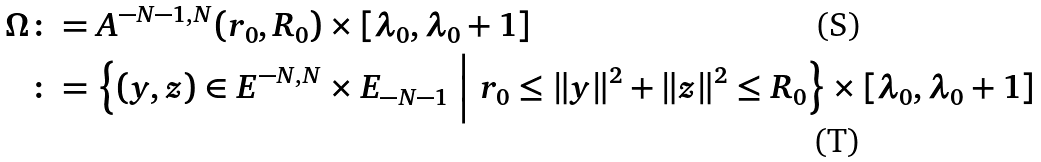<formula> <loc_0><loc_0><loc_500><loc_500>\Omega & \colon = A ^ { - N - 1 , N } ( r _ { 0 } , R _ { 0 } ) \times [ \lambda _ { 0 } , \lambda _ { 0 } + 1 ] \\ & \colon = \Big \{ ( y , z ) \in E ^ { - N , N } \times E _ { - N - 1 } \ \Big | \ r _ { 0 } \leq \| y \| ^ { 2 } + \| z \| ^ { 2 } \leq R _ { 0 } \Big \} \times [ \lambda _ { 0 } , \lambda _ { 0 } + 1 ]</formula> 